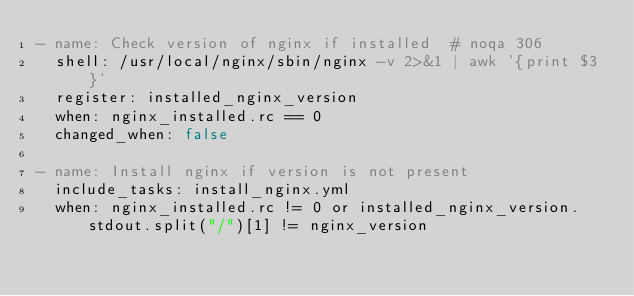<code> <loc_0><loc_0><loc_500><loc_500><_YAML_>- name: Check version of nginx if installed  # noqa 306
  shell: /usr/local/nginx/sbin/nginx -v 2>&1 | awk '{print $3}'
  register: installed_nginx_version
  when: nginx_installed.rc == 0
  changed_when: false

- name: Install nginx if version is not present
  include_tasks: install_nginx.yml
  when: nginx_installed.rc != 0 or installed_nginx_version.stdout.split("/")[1] != nginx_version
</code> 